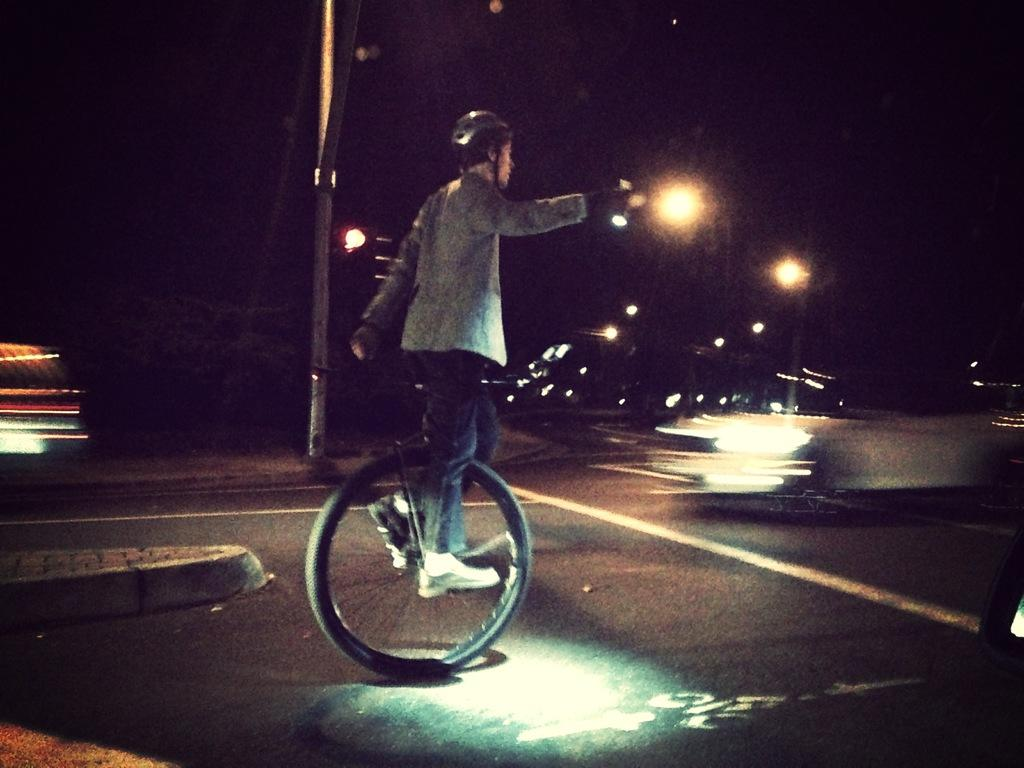What is the person in the image doing? The person is on a wheel in the image. What type of path is visible in the image? There is a road in the image. What can be seen illuminating the road in the image? There are street lights in the image. What type of bit is the person using to communicate with the street lights in the image? There is: There is no bit present in the image, and the person is not communicating with the street lights. 